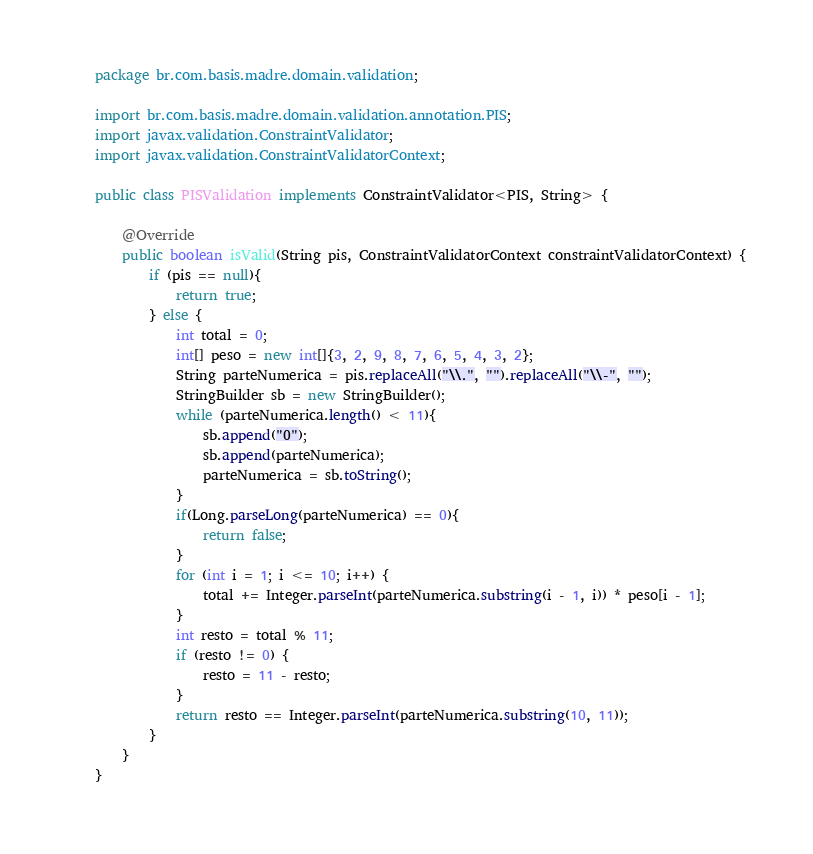<code> <loc_0><loc_0><loc_500><loc_500><_Java_>package br.com.basis.madre.domain.validation;

import br.com.basis.madre.domain.validation.annotation.PIS;
import javax.validation.ConstraintValidator;
import javax.validation.ConstraintValidatorContext;

public class PISValidation implements ConstraintValidator<PIS, String> {

    @Override
    public boolean isValid(String pis, ConstraintValidatorContext constraintValidatorContext) {
        if (pis == null){
            return true;
        } else {
            int total = 0;
            int[] peso = new int[]{3, 2, 9, 8, 7, 6, 5, 4, 3, 2};
            String parteNumerica = pis.replaceAll("\\.", "").replaceAll("\\-", "");
            StringBuilder sb = new StringBuilder();
            while (parteNumerica.length() < 11){
                sb.append("0");
                sb.append(parteNumerica);
                parteNumerica = sb.toString();
            }
            if(Long.parseLong(parteNumerica) == 0){
                return false;
            }
            for (int i = 1; i <= 10; i++) {
                total += Integer.parseInt(parteNumerica.substring(i - 1, i)) * peso[i - 1];
            }
            int resto = total % 11;
            if (resto != 0) {
                resto = 11 - resto;
            }
            return resto == Integer.parseInt(parteNumerica.substring(10, 11));
        }
    }
}
</code> 